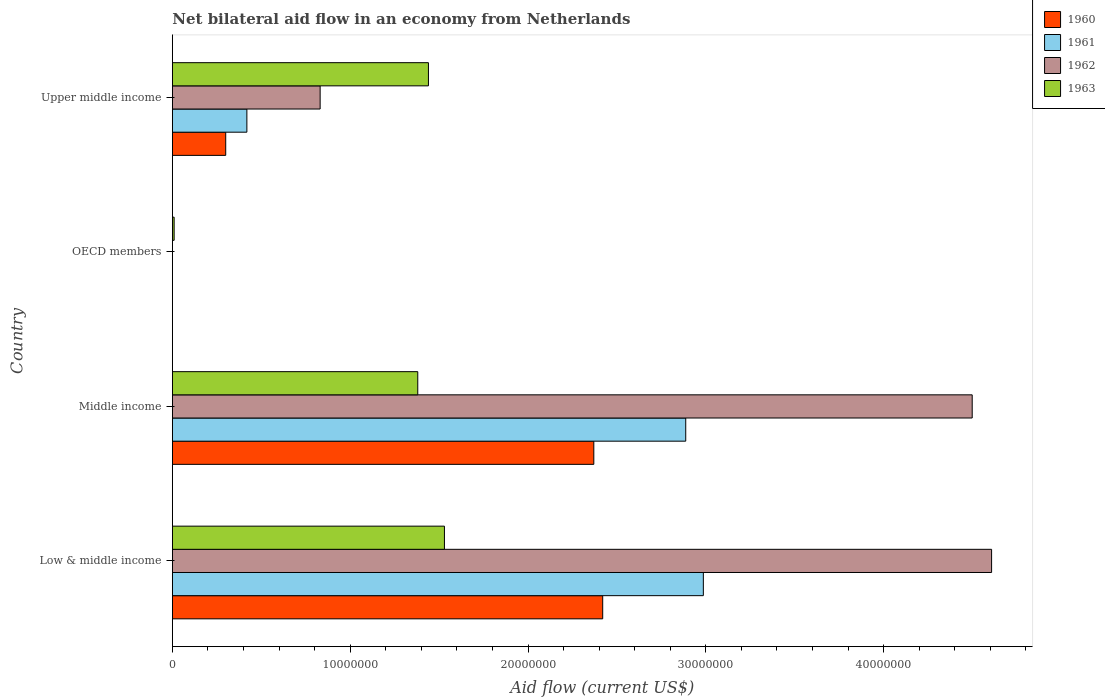How many bars are there on the 3rd tick from the top?
Ensure brevity in your answer.  4. How many bars are there on the 1st tick from the bottom?
Your response must be concise. 4. What is the net bilateral aid flow in 1960 in Middle income?
Give a very brief answer. 2.37e+07. Across all countries, what is the maximum net bilateral aid flow in 1960?
Provide a succinct answer. 2.42e+07. What is the total net bilateral aid flow in 1963 in the graph?
Your response must be concise. 4.36e+07. What is the difference between the net bilateral aid flow in 1963 in OECD members and that in Upper middle income?
Offer a very short reply. -1.43e+07. What is the difference between the net bilateral aid flow in 1963 in OECD members and the net bilateral aid flow in 1960 in Low & middle income?
Provide a succinct answer. -2.41e+07. What is the average net bilateral aid flow in 1963 per country?
Offer a terse response. 1.09e+07. What is the difference between the net bilateral aid flow in 1961 and net bilateral aid flow in 1962 in Middle income?
Give a very brief answer. -1.61e+07. What is the ratio of the net bilateral aid flow in 1963 in Middle income to that in Upper middle income?
Ensure brevity in your answer.  0.96. Is the net bilateral aid flow in 1961 in Middle income less than that in Upper middle income?
Ensure brevity in your answer.  No. Is the difference between the net bilateral aid flow in 1961 in Middle income and Upper middle income greater than the difference between the net bilateral aid flow in 1962 in Middle income and Upper middle income?
Your response must be concise. No. What is the difference between the highest and the lowest net bilateral aid flow in 1961?
Ensure brevity in your answer.  2.99e+07. In how many countries, is the net bilateral aid flow in 1960 greater than the average net bilateral aid flow in 1960 taken over all countries?
Your answer should be compact. 2. How many bars are there?
Make the answer very short. 13. How many countries are there in the graph?
Make the answer very short. 4. What is the difference between two consecutive major ticks on the X-axis?
Provide a short and direct response. 1.00e+07. Does the graph contain grids?
Your answer should be compact. No. Where does the legend appear in the graph?
Keep it short and to the point. Top right. What is the title of the graph?
Your response must be concise. Net bilateral aid flow in an economy from Netherlands. What is the label or title of the Y-axis?
Provide a succinct answer. Country. What is the Aid flow (current US$) in 1960 in Low & middle income?
Ensure brevity in your answer.  2.42e+07. What is the Aid flow (current US$) of 1961 in Low & middle income?
Ensure brevity in your answer.  2.99e+07. What is the Aid flow (current US$) of 1962 in Low & middle income?
Offer a terse response. 4.61e+07. What is the Aid flow (current US$) of 1963 in Low & middle income?
Provide a succinct answer. 1.53e+07. What is the Aid flow (current US$) of 1960 in Middle income?
Your response must be concise. 2.37e+07. What is the Aid flow (current US$) of 1961 in Middle income?
Ensure brevity in your answer.  2.89e+07. What is the Aid flow (current US$) in 1962 in Middle income?
Your answer should be very brief. 4.50e+07. What is the Aid flow (current US$) of 1963 in Middle income?
Your answer should be very brief. 1.38e+07. What is the Aid flow (current US$) in 1960 in OECD members?
Provide a short and direct response. 0. What is the Aid flow (current US$) in 1961 in OECD members?
Give a very brief answer. 0. What is the Aid flow (current US$) in 1962 in OECD members?
Give a very brief answer. 0. What is the Aid flow (current US$) in 1963 in OECD members?
Make the answer very short. 1.00e+05. What is the Aid flow (current US$) in 1961 in Upper middle income?
Offer a very short reply. 4.19e+06. What is the Aid flow (current US$) in 1962 in Upper middle income?
Provide a succinct answer. 8.31e+06. What is the Aid flow (current US$) in 1963 in Upper middle income?
Provide a succinct answer. 1.44e+07. Across all countries, what is the maximum Aid flow (current US$) in 1960?
Keep it short and to the point. 2.42e+07. Across all countries, what is the maximum Aid flow (current US$) of 1961?
Give a very brief answer. 2.99e+07. Across all countries, what is the maximum Aid flow (current US$) of 1962?
Your answer should be compact. 4.61e+07. Across all countries, what is the maximum Aid flow (current US$) in 1963?
Offer a very short reply. 1.53e+07. Across all countries, what is the minimum Aid flow (current US$) in 1960?
Provide a short and direct response. 0. Across all countries, what is the minimum Aid flow (current US$) in 1961?
Ensure brevity in your answer.  0. Across all countries, what is the minimum Aid flow (current US$) of 1962?
Provide a succinct answer. 0. What is the total Aid flow (current US$) in 1960 in the graph?
Offer a terse response. 5.09e+07. What is the total Aid flow (current US$) in 1961 in the graph?
Provide a succinct answer. 6.29e+07. What is the total Aid flow (current US$) of 1962 in the graph?
Make the answer very short. 9.94e+07. What is the total Aid flow (current US$) of 1963 in the graph?
Make the answer very short. 4.36e+07. What is the difference between the Aid flow (current US$) of 1961 in Low & middle income and that in Middle income?
Ensure brevity in your answer.  9.90e+05. What is the difference between the Aid flow (current US$) of 1962 in Low & middle income and that in Middle income?
Offer a very short reply. 1.09e+06. What is the difference between the Aid flow (current US$) of 1963 in Low & middle income and that in Middle income?
Give a very brief answer. 1.50e+06. What is the difference between the Aid flow (current US$) in 1963 in Low & middle income and that in OECD members?
Offer a terse response. 1.52e+07. What is the difference between the Aid flow (current US$) in 1960 in Low & middle income and that in Upper middle income?
Offer a terse response. 2.12e+07. What is the difference between the Aid flow (current US$) of 1961 in Low & middle income and that in Upper middle income?
Your answer should be very brief. 2.57e+07. What is the difference between the Aid flow (current US$) of 1962 in Low & middle income and that in Upper middle income?
Offer a terse response. 3.78e+07. What is the difference between the Aid flow (current US$) in 1963 in Middle income and that in OECD members?
Offer a terse response. 1.37e+07. What is the difference between the Aid flow (current US$) in 1960 in Middle income and that in Upper middle income?
Keep it short and to the point. 2.07e+07. What is the difference between the Aid flow (current US$) of 1961 in Middle income and that in Upper middle income?
Make the answer very short. 2.47e+07. What is the difference between the Aid flow (current US$) of 1962 in Middle income and that in Upper middle income?
Your answer should be compact. 3.67e+07. What is the difference between the Aid flow (current US$) of 1963 in Middle income and that in Upper middle income?
Offer a very short reply. -6.00e+05. What is the difference between the Aid flow (current US$) of 1963 in OECD members and that in Upper middle income?
Offer a terse response. -1.43e+07. What is the difference between the Aid flow (current US$) of 1960 in Low & middle income and the Aid flow (current US$) of 1961 in Middle income?
Offer a very short reply. -4.67e+06. What is the difference between the Aid flow (current US$) of 1960 in Low & middle income and the Aid flow (current US$) of 1962 in Middle income?
Give a very brief answer. -2.08e+07. What is the difference between the Aid flow (current US$) of 1960 in Low & middle income and the Aid flow (current US$) of 1963 in Middle income?
Offer a very short reply. 1.04e+07. What is the difference between the Aid flow (current US$) in 1961 in Low & middle income and the Aid flow (current US$) in 1962 in Middle income?
Your answer should be very brief. -1.51e+07. What is the difference between the Aid flow (current US$) of 1961 in Low & middle income and the Aid flow (current US$) of 1963 in Middle income?
Provide a short and direct response. 1.61e+07. What is the difference between the Aid flow (current US$) of 1962 in Low & middle income and the Aid flow (current US$) of 1963 in Middle income?
Ensure brevity in your answer.  3.23e+07. What is the difference between the Aid flow (current US$) in 1960 in Low & middle income and the Aid flow (current US$) in 1963 in OECD members?
Your answer should be compact. 2.41e+07. What is the difference between the Aid flow (current US$) of 1961 in Low & middle income and the Aid flow (current US$) of 1963 in OECD members?
Make the answer very short. 2.98e+07. What is the difference between the Aid flow (current US$) of 1962 in Low & middle income and the Aid flow (current US$) of 1963 in OECD members?
Give a very brief answer. 4.60e+07. What is the difference between the Aid flow (current US$) of 1960 in Low & middle income and the Aid flow (current US$) of 1961 in Upper middle income?
Provide a short and direct response. 2.00e+07. What is the difference between the Aid flow (current US$) of 1960 in Low & middle income and the Aid flow (current US$) of 1962 in Upper middle income?
Provide a succinct answer. 1.59e+07. What is the difference between the Aid flow (current US$) of 1960 in Low & middle income and the Aid flow (current US$) of 1963 in Upper middle income?
Offer a very short reply. 9.80e+06. What is the difference between the Aid flow (current US$) in 1961 in Low & middle income and the Aid flow (current US$) in 1962 in Upper middle income?
Keep it short and to the point. 2.16e+07. What is the difference between the Aid flow (current US$) in 1961 in Low & middle income and the Aid flow (current US$) in 1963 in Upper middle income?
Your answer should be compact. 1.55e+07. What is the difference between the Aid flow (current US$) of 1962 in Low & middle income and the Aid flow (current US$) of 1963 in Upper middle income?
Keep it short and to the point. 3.17e+07. What is the difference between the Aid flow (current US$) in 1960 in Middle income and the Aid flow (current US$) in 1963 in OECD members?
Your answer should be compact. 2.36e+07. What is the difference between the Aid flow (current US$) of 1961 in Middle income and the Aid flow (current US$) of 1963 in OECD members?
Give a very brief answer. 2.88e+07. What is the difference between the Aid flow (current US$) of 1962 in Middle income and the Aid flow (current US$) of 1963 in OECD members?
Ensure brevity in your answer.  4.49e+07. What is the difference between the Aid flow (current US$) in 1960 in Middle income and the Aid flow (current US$) in 1961 in Upper middle income?
Your answer should be compact. 1.95e+07. What is the difference between the Aid flow (current US$) of 1960 in Middle income and the Aid flow (current US$) of 1962 in Upper middle income?
Keep it short and to the point. 1.54e+07. What is the difference between the Aid flow (current US$) in 1960 in Middle income and the Aid flow (current US$) in 1963 in Upper middle income?
Give a very brief answer. 9.30e+06. What is the difference between the Aid flow (current US$) of 1961 in Middle income and the Aid flow (current US$) of 1962 in Upper middle income?
Your answer should be very brief. 2.06e+07. What is the difference between the Aid flow (current US$) in 1961 in Middle income and the Aid flow (current US$) in 1963 in Upper middle income?
Make the answer very short. 1.45e+07. What is the difference between the Aid flow (current US$) in 1962 in Middle income and the Aid flow (current US$) in 1963 in Upper middle income?
Give a very brief answer. 3.06e+07. What is the average Aid flow (current US$) of 1960 per country?
Offer a terse response. 1.27e+07. What is the average Aid flow (current US$) in 1961 per country?
Your response must be concise. 1.57e+07. What is the average Aid flow (current US$) in 1962 per country?
Make the answer very short. 2.48e+07. What is the average Aid flow (current US$) of 1963 per country?
Your response must be concise. 1.09e+07. What is the difference between the Aid flow (current US$) of 1960 and Aid flow (current US$) of 1961 in Low & middle income?
Your answer should be compact. -5.66e+06. What is the difference between the Aid flow (current US$) of 1960 and Aid flow (current US$) of 1962 in Low & middle income?
Offer a very short reply. -2.19e+07. What is the difference between the Aid flow (current US$) of 1960 and Aid flow (current US$) of 1963 in Low & middle income?
Make the answer very short. 8.90e+06. What is the difference between the Aid flow (current US$) of 1961 and Aid flow (current US$) of 1962 in Low & middle income?
Offer a very short reply. -1.62e+07. What is the difference between the Aid flow (current US$) of 1961 and Aid flow (current US$) of 1963 in Low & middle income?
Offer a terse response. 1.46e+07. What is the difference between the Aid flow (current US$) of 1962 and Aid flow (current US$) of 1963 in Low & middle income?
Your response must be concise. 3.08e+07. What is the difference between the Aid flow (current US$) of 1960 and Aid flow (current US$) of 1961 in Middle income?
Make the answer very short. -5.17e+06. What is the difference between the Aid flow (current US$) of 1960 and Aid flow (current US$) of 1962 in Middle income?
Give a very brief answer. -2.13e+07. What is the difference between the Aid flow (current US$) in 1960 and Aid flow (current US$) in 1963 in Middle income?
Ensure brevity in your answer.  9.90e+06. What is the difference between the Aid flow (current US$) in 1961 and Aid flow (current US$) in 1962 in Middle income?
Provide a short and direct response. -1.61e+07. What is the difference between the Aid flow (current US$) in 1961 and Aid flow (current US$) in 1963 in Middle income?
Your answer should be compact. 1.51e+07. What is the difference between the Aid flow (current US$) in 1962 and Aid flow (current US$) in 1963 in Middle income?
Ensure brevity in your answer.  3.12e+07. What is the difference between the Aid flow (current US$) in 1960 and Aid flow (current US$) in 1961 in Upper middle income?
Keep it short and to the point. -1.19e+06. What is the difference between the Aid flow (current US$) in 1960 and Aid flow (current US$) in 1962 in Upper middle income?
Keep it short and to the point. -5.31e+06. What is the difference between the Aid flow (current US$) of 1960 and Aid flow (current US$) of 1963 in Upper middle income?
Your answer should be compact. -1.14e+07. What is the difference between the Aid flow (current US$) in 1961 and Aid flow (current US$) in 1962 in Upper middle income?
Provide a succinct answer. -4.12e+06. What is the difference between the Aid flow (current US$) of 1961 and Aid flow (current US$) of 1963 in Upper middle income?
Provide a short and direct response. -1.02e+07. What is the difference between the Aid flow (current US$) of 1962 and Aid flow (current US$) of 1963 in Upper middle income?
Provide a short and direct response. -6.09e+06. What is the ratio of the Aid flow (current US$) of 1960 in Low & middle income to that in Middle income?
Offer a terse response. 1.02. What is the ratio of the Aid flow (current US$) of 1961 in Low & middle income to that in Middle income?
Make the answer very short. 1.03. What is the ratio of the Aid flow (current US$) in 1962 in Low & middle income to that in Middle income?
Your response must be concise. 1.02. What is the ratio of the Aid flow (current US$) of 1963 in Low & middle income to that in Middle income?
Give a very brief answer. 1.11. What is the ratio of the Aid flow (current US$) in 1963 in Low & middle income to that in OECD members?
Provide a short and direct response. 153. What is the ratio of the Aid flow (current US$) in 1960 in Low & middle income to that in Upper middle income?
Your answer should be compact. 8.07. What is the ratio of the Aid flow (current US$) of 1961 in Low & middle income to that in Upper middle income?
Keep it short and to the point. 7.13. What is the ratio of the Aid flow (current US$) of 1962 in Low & middle income to that in Upper middle income?
Keep it short and to the point. 5.54. What is the ratio of the Aid flow (current US$) in 1963 in Middle income to that in OECD members?
Make the answer very short. 138. What is the ratio of the Aid flow (current US$) in 1960 in Middle income to that in Upper middle income?
Ensure brevity in your answer.  7.9. What is the ratio of the Aid flow (current US$) in 1961 in Middle income to that in Upper middle income?
Make the answer very short. 6.89. What is the ratio of the Aid flow (current US$) in 1962 in Middle income to that in Upper middle income?
Keep it short and to the point. 5.41. What is the ratio of the Aid flow (current US$) of 1963 in OECD members to that in Upper middle income?
Offer a terse response. 0.01. What is the difference between the highest and the second highest Aid flow (current US$) in 1961?
Offer a very short reply. 9.90e+05. What is the difference between the highest and the second highest Aid flow (current US$) in 1962?
Provide a short and direct response. 1.09e+06. What is the difference between the highest and the lowest Aid flow (current US$) in 1960?
Keep it short and to the point. 2.42e+07. What is the difference between the highest and the lowest Aid flow (current US$) of 1961?
Make the answer very short. 2.99e+07. What is the difference between the highest and the lowest Aid flow (current US$) of 1962?
Ensure brevity in your answer.  4.61e+07. What is the difference between the highest and the lowest Aid flow (current US$) of 1963?
Offer a very short reply. 1.52e+07. 